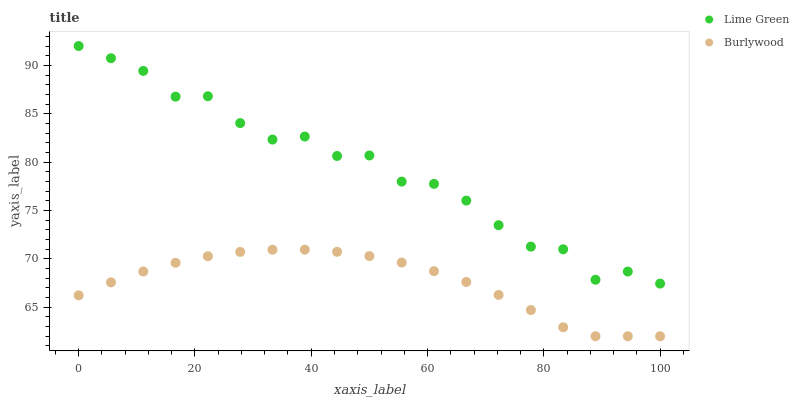Does Burlywood have the minimum area under the curve?
Answer yes or no. Yes. Does Lime Green have the maximum area under the curve?
Answer yes or no. Yes. Does Lime Green have the minimum area under the curve?
Answer yes or no. No. Is Burlywood the smoothest?
Answer yes or no. Yes. Is Lime Green the roughest?
Answer yes or no. Yes. Is Lime Green the smoothest?
Answer yes or no. No. Does Burlywood have the lowest value?
Answer yes or no. Yes. Does Lime Green have the lowest value?
Answer yes or no. No. Does Lime Green have the highest value?
Answer yes or no. Yes. Is Burlywood less than Lime Green?
Answer yes or no. Yes. Is Lime Green greater than Burlywood?
Answer yes or no. Yes. Does Burlywood intersect Lime Green?
Answer yes or no. No. 